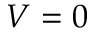Convert formula to latex. <formula><loc_0><loc_0><loc_500><loc_500>V = 0</formula> 